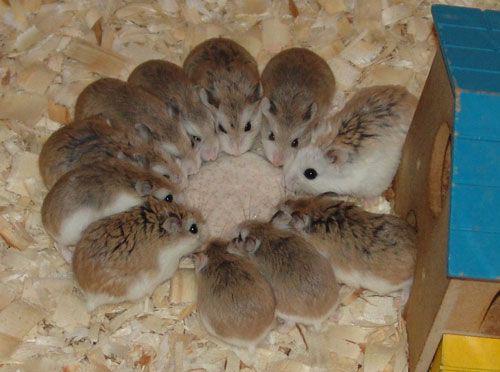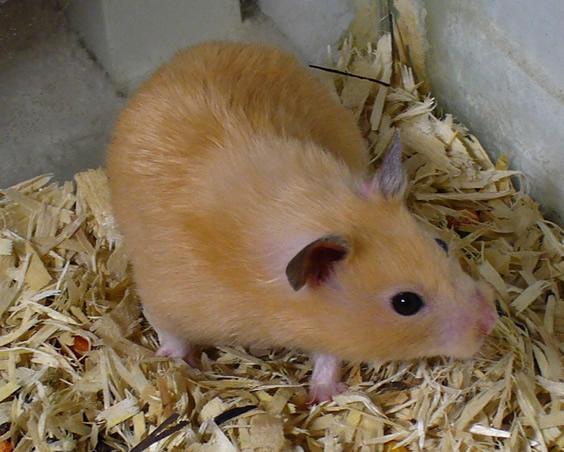The first image is the image on the left, the second image is the image on the right. Considering the images on both sides, is "There are at least two newborn rodents." valid? Answer yes or no. No. The first image is the image on the left, the second image is the image on the right. Analyze the images presented: Is the assertion "An image shows one adult rodent with more than one newborn nearby." valid? Answer yes or no. No. 